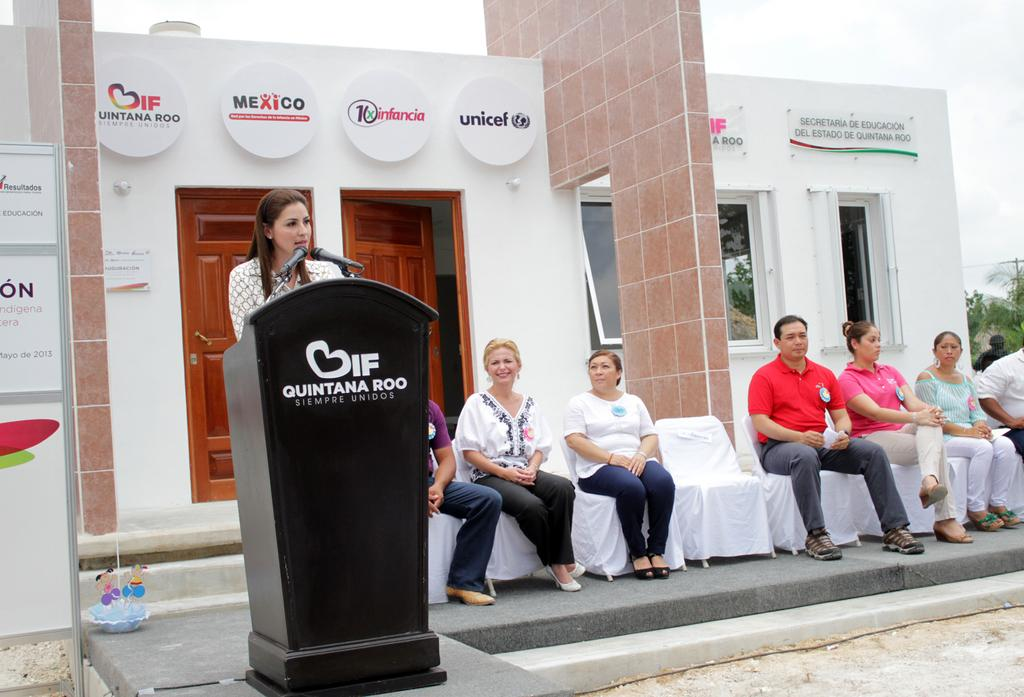Provide a one-sentence caption for the provided image. A woman at a Quintana Roo podium is giving a speech. 